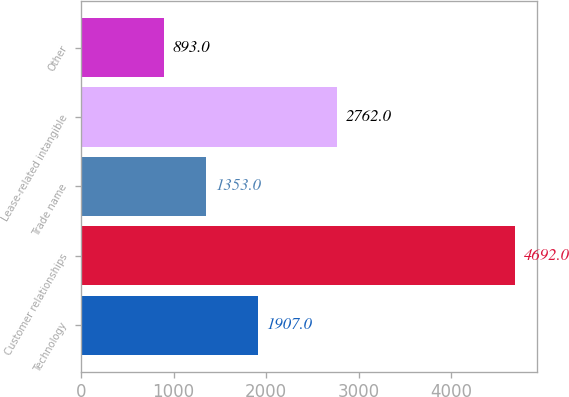Convert chart to OTSL. <chart><loc_0><loc_0><loc_500><loc_500><bar_chart><fcel>Technology<fcel>Customer relationships<fcel>Trade name<fcel>Lease-related intangible<fcel>Other<nl><fcel>1907<fcel>4692<fcel>1353<fcel>2762<fcel>893<nl></chart> 